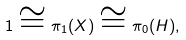<formula> <loc_0><loc_0><loc_500><loc_500>\label l { e \colon p i 0 H } 1 \cong \pi _ { 1 } ( X ) \cong \pi _ { 0 } ( H ) ,</formula> 